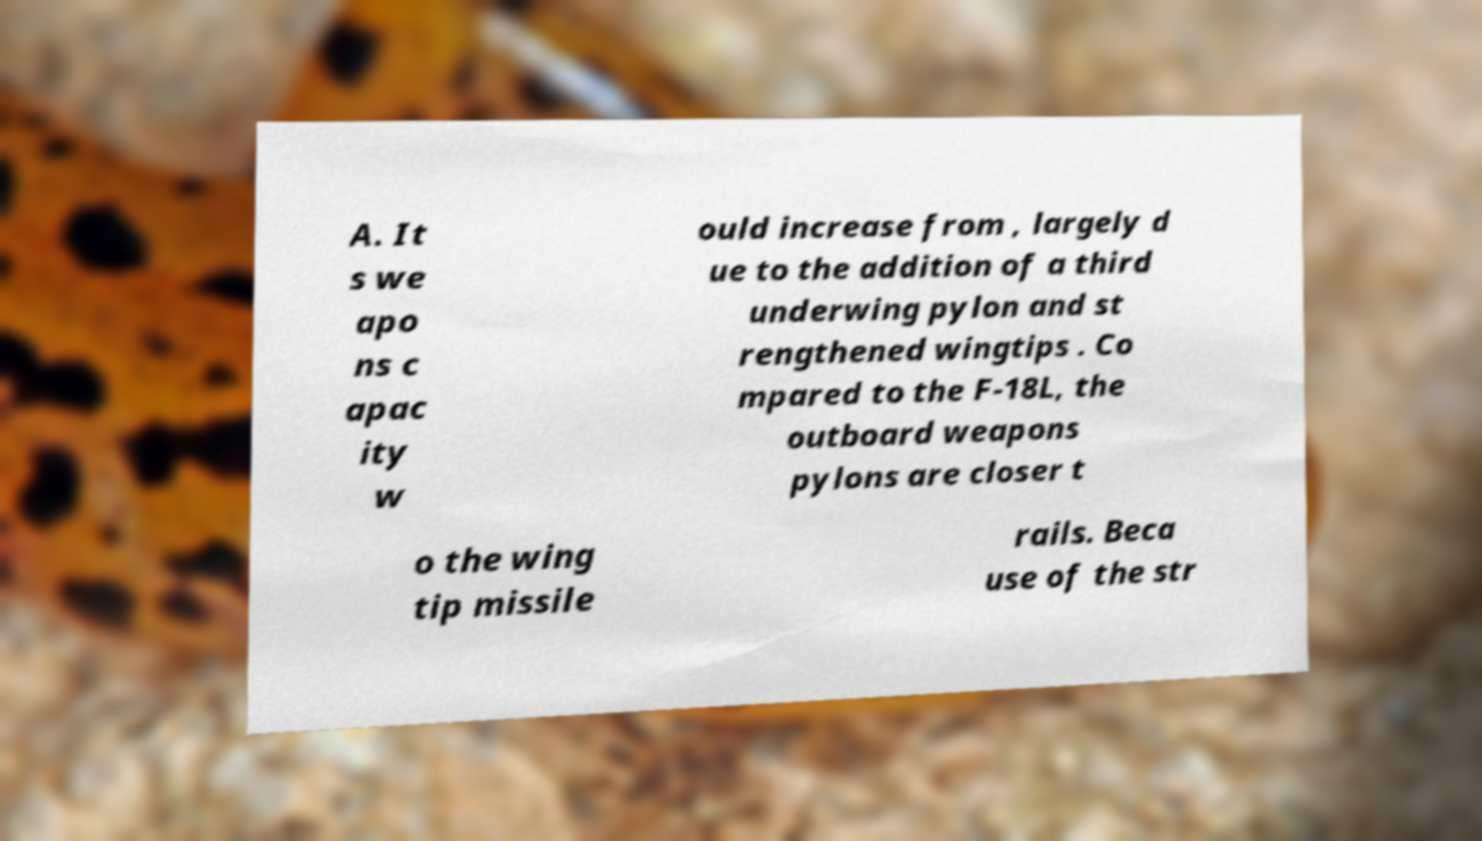Could you extract and type out the text from this image? A. It s we apo ns c apac ity w ould increase from , largely d ue to the addition of a third underwing pylon and st rengthened wingtips . Co mpared to the F-18L, the outboard weapons pylons are closer t o the wing tip missile rails. Beca use of the str 